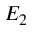Convert formula to latex. <formula><loc_0><loc_0><loc_500><loc_500>E _ { 2 }</formula> 